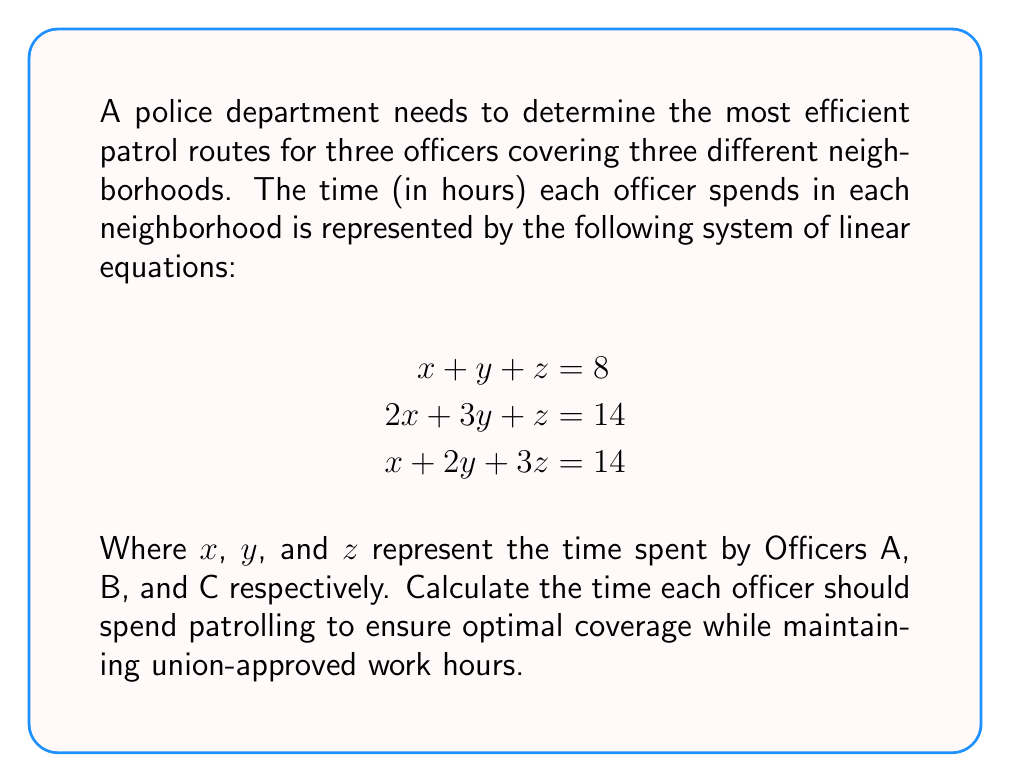Can you solve this math problem? To solve this system of linear equations, we'll use the Gaussian elimination method:

1) First, write the augmented matrix:
   $$\begin{bmatrix}
   1 & 1 & 1 & 8 \\
   2 & 3 & 1 & 14 \\
   1 & 2 & 3 & 14
   \end{bmatrix}$$

2) Subtract 2 times the first row from the second row:
   $$\begin{bmatrix}
   1 & 1 & 1 & 8 \\
   0 & 1 & -1 & -2 \\
   1 & 2 & 3 & 14
   \end{bmatrix}$$

3) Subtract the first row from the third row:
   $$\begin{bmatrix}
   1 & 1 & 1 & 8 \\
   0 & 1 & -1 & -2 \\
   0 & 1 & 2 & 6
   \end{bmatrix}$$

4) Subtract the second row from the third row:
   $$\begin{bmatrix}
   1 & 1 & 1 & 8 \\
   0 & 1 & -1 & -2 \\
   0 & 0 & 3 & 8
   \end{bmatrix}$$

5) Now we have an upper triangular matrix. Solve for z:
   $3z = 8$, so $z = \frac{8}{3}$

6) Substitute z into the second equation:
   $y - (-1)(\frac{8}{3}) = -2$
   $y + \frac{8}{3} = -2$
   $y = -2 - \frac{8}{3} = -\frac{14}{3}$

7) Substitute y and z into the first equation:
   $x + (-\frac{14}{3}) + \frac{8}{3} = 8$
   $x - 2 = 8$
   $x = 10$

Therefore, Officer A (x) should patrol for 10 hours, Officer B (y) for $-\frac{14}{3}$ hours, and Officer C (z) for $\frac{8}{3}$ hours.

However, since negative time is not possible, we need to interpret these results in the context of our police union perspective. The negative value for Officer B suggests that the current system is overworking some officers while underutilizing others, which could be a point of concern for the union.
Answer: $x = 10, y = -\frac{14}{3}, z = \frac{8}{3}$ 